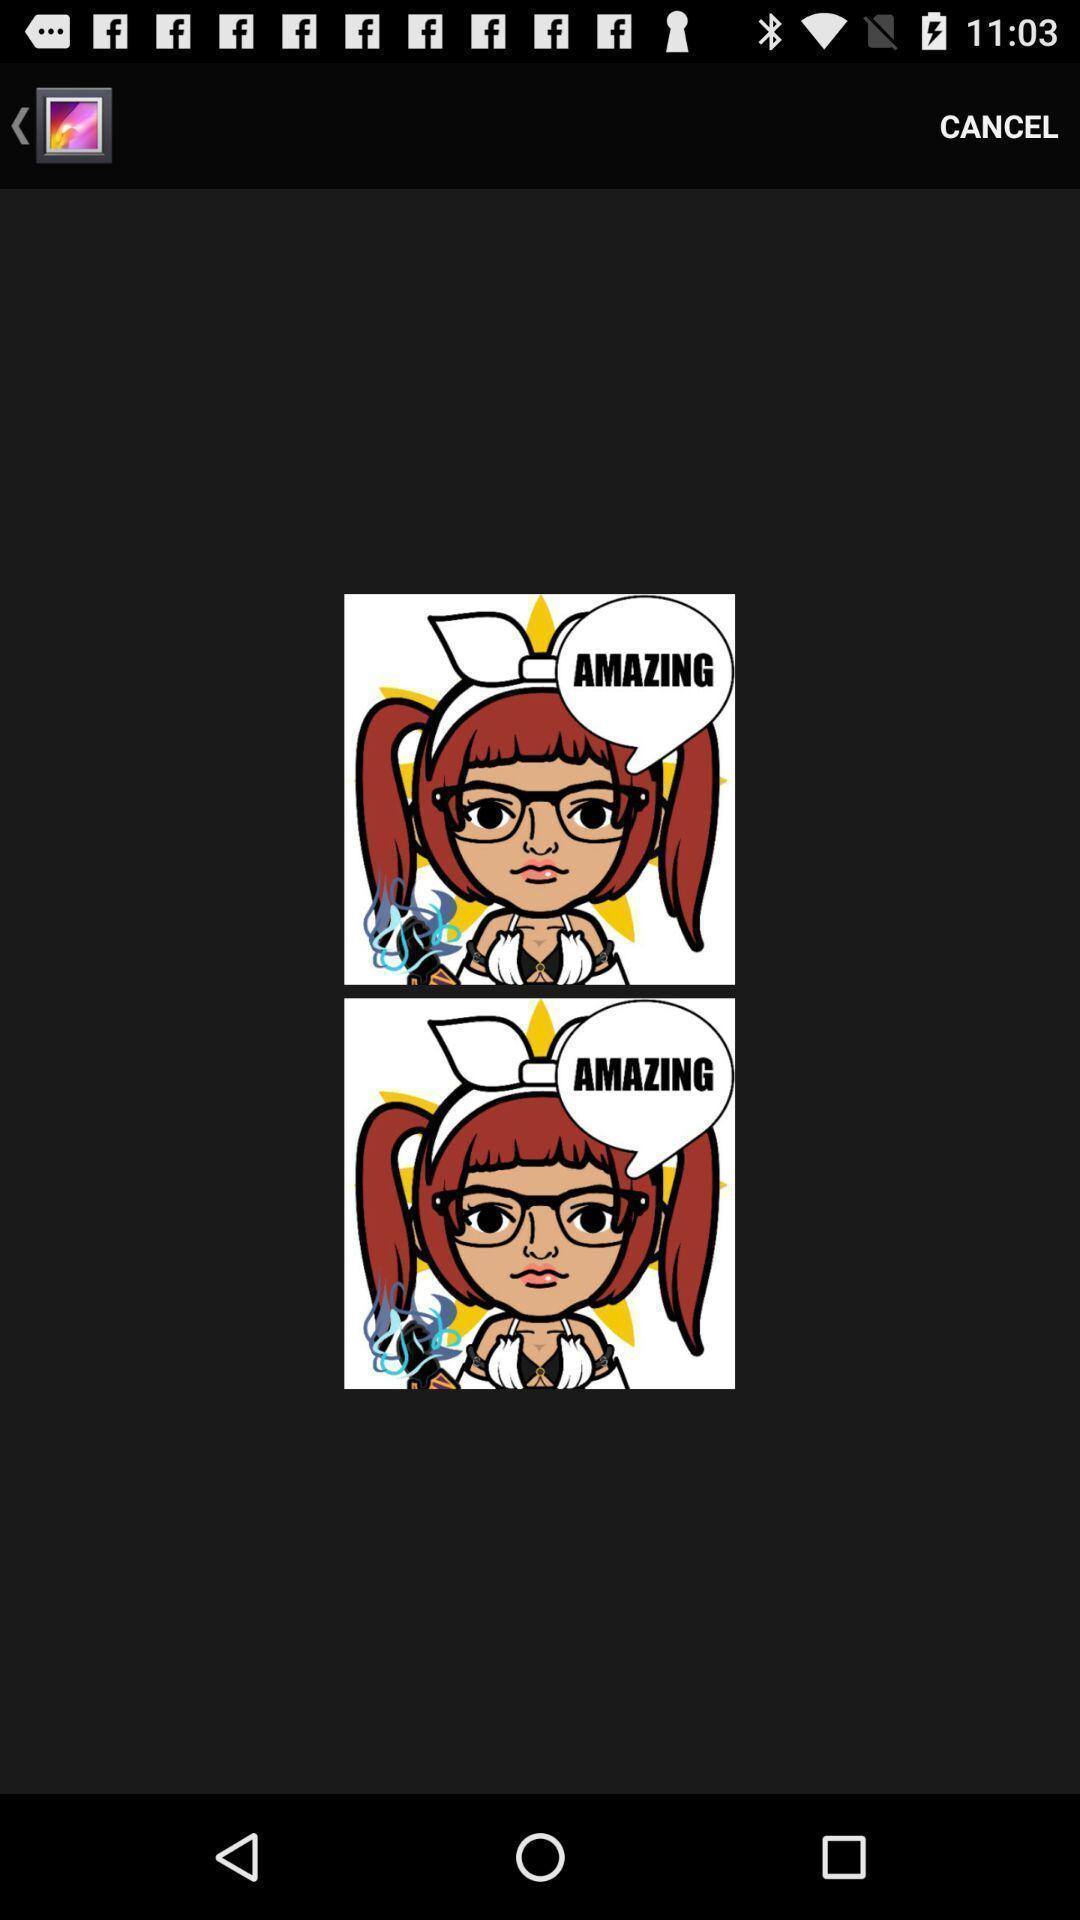Describe the key features of this screenshot. Page showing cartoon image of girl. 